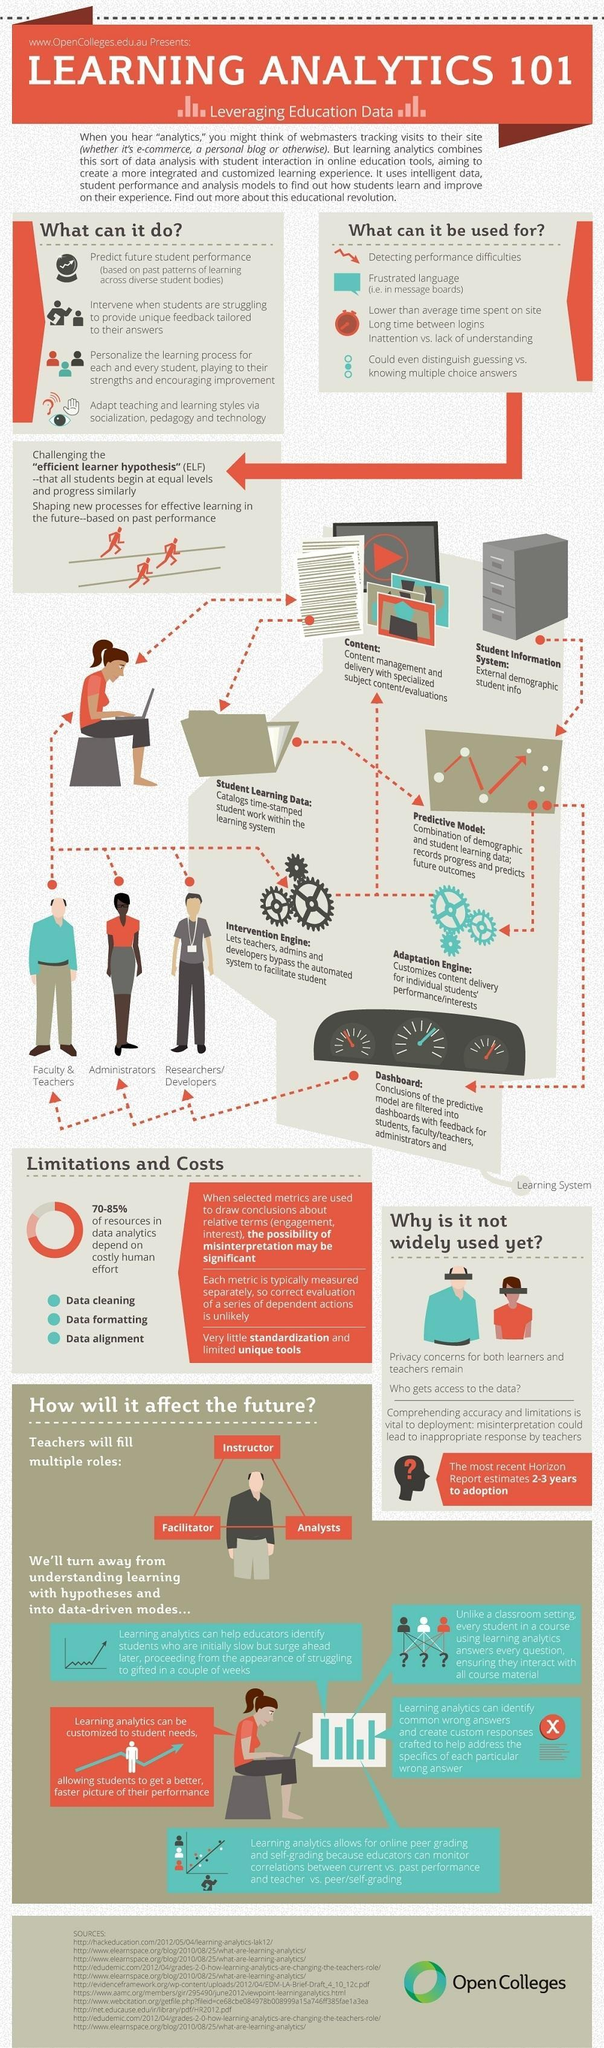Which all are the other roles of teachers?
Answer the question with a short phrase. Instructor, Facilitator, Analysts In which way data is arranged and accessed in computer memory? Data alignment 